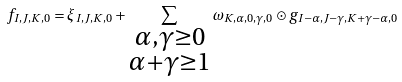<formula> <loc_0><loc_0><loc_500><loc_500>f _ { I , J , K , 0 } = \xi _ { I , J , K , 0 } + \sum _ { \substack { \alpha , \gamma \geq 0 \\ \alpha + \gamma \geq 1 } } \omega _ { K , \alpha , 0 , \gamma , 0 } \odot g _ { I - \alpha , J - \gamma , K + \gamma - \alpha , 0 }</formula> 